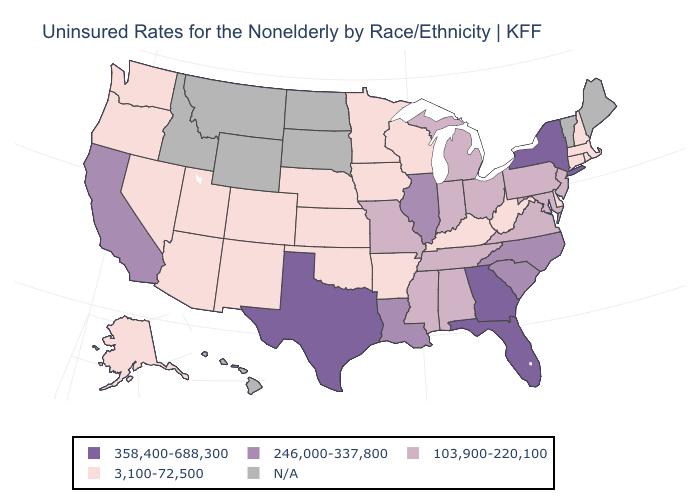Does Georgia have the highest value in the USA?
Be succinct. Yes. Is the legend a continuous bar?
Write a very short answer. No. Name the states that have a value in the range N/A?
Quick response, please. Hawaii, Idaho, Maine, Montana, North Dakota, South Dakota, Vermont, Wyoming. Which states have the lowest value in the USA?
Be succinct. Alaska, Arizona, Arkansas, Colorado, Connecticut, Delaware, Iowa, Kansas, Kentucky, Massachusetts, Minnesota, Nebraska, Nevada, New Hampshire, New Mexico, Oklahoma, Oregon, Rhode Island, Utah, Washington, West Virginia, Wisconsin. What is the lowest value in states that border Arizona?
Give a very brief answer. 3,100-72,500. Does the map have missing data?
Concise answer only. Yes. Does the first symbol in the legend represent the smallest category?
Be succinct. No. What is the value of Tennessee?
Write a very short answer. 103,900-220,100. Name the states that have a value in the range N/A?
Write a very short answer. Hawaii, Idaho, Maine, Montana, North Dakota, South Dakota, Vermont, Wyoming. Name the states that have a value in the range 246,000-337,800?
Quick response, please. California, Illinois, Louisiana, North Carolina, South Carolina. Name the states that have a value in the range 246,000-337,800?
Concise answer only. California, Illinois, Louisiana, North Carolina, South Carolina. What is the lowest value in the USA?
Write a very short answer. 3,100-72,500. Name the states that have a value in the range 3,100-72,500?
Keep it brief. Alaska, Arizona, Arkansas, Colorado, Connecticut, Delaware, Iowa, Kansas, Kentucky, Massachusetts, Minnesota, Nebraska, Nevada, New Hampshire, New Mexico, Oklahoma, Oregon, Rhode Island, Utah, Washington, West Virginia, Wisconsin. What is the value of Idaho?
Be succinct. N/A. 